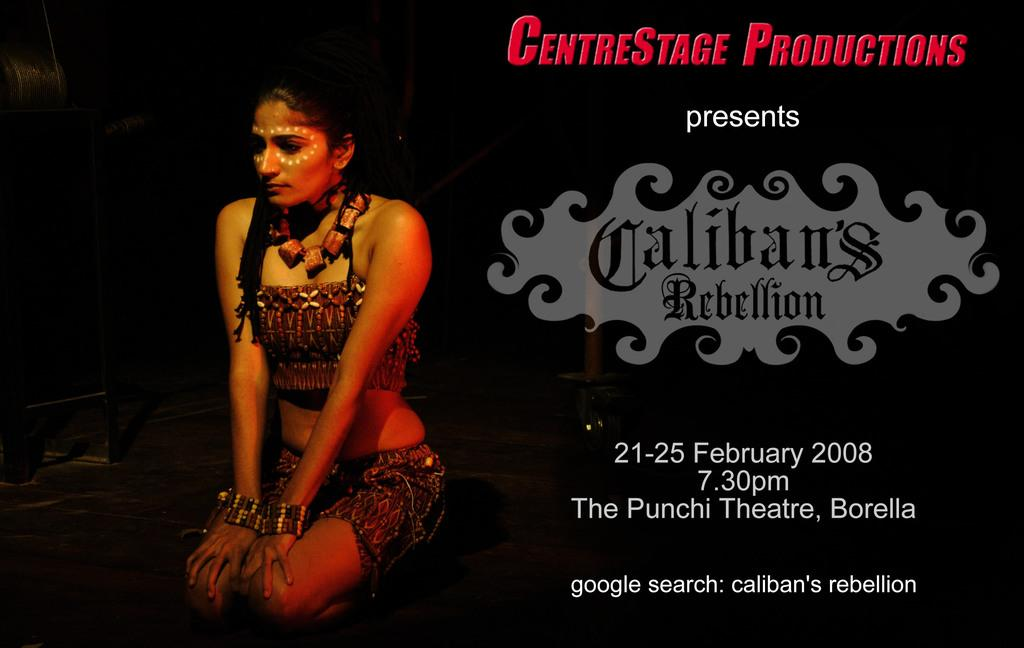What is the main subject of the image? The main subject of the image is a promotion of an event. What information is provided about the event in the image? There is text associated with the event promotion in the image. What can be seen in the image besides the event promotion? There is a lady person wearing a different costume in the image. What is the lady person doing in the image? The lady person is crouching down. What type of patch can be seen on the lady person's costume in the image? There is no patch visible on the lady person's costume in the image. How does the rain affect the event promotion in the image? There is no rain present in the image, so it cannot affect the event promotion. 